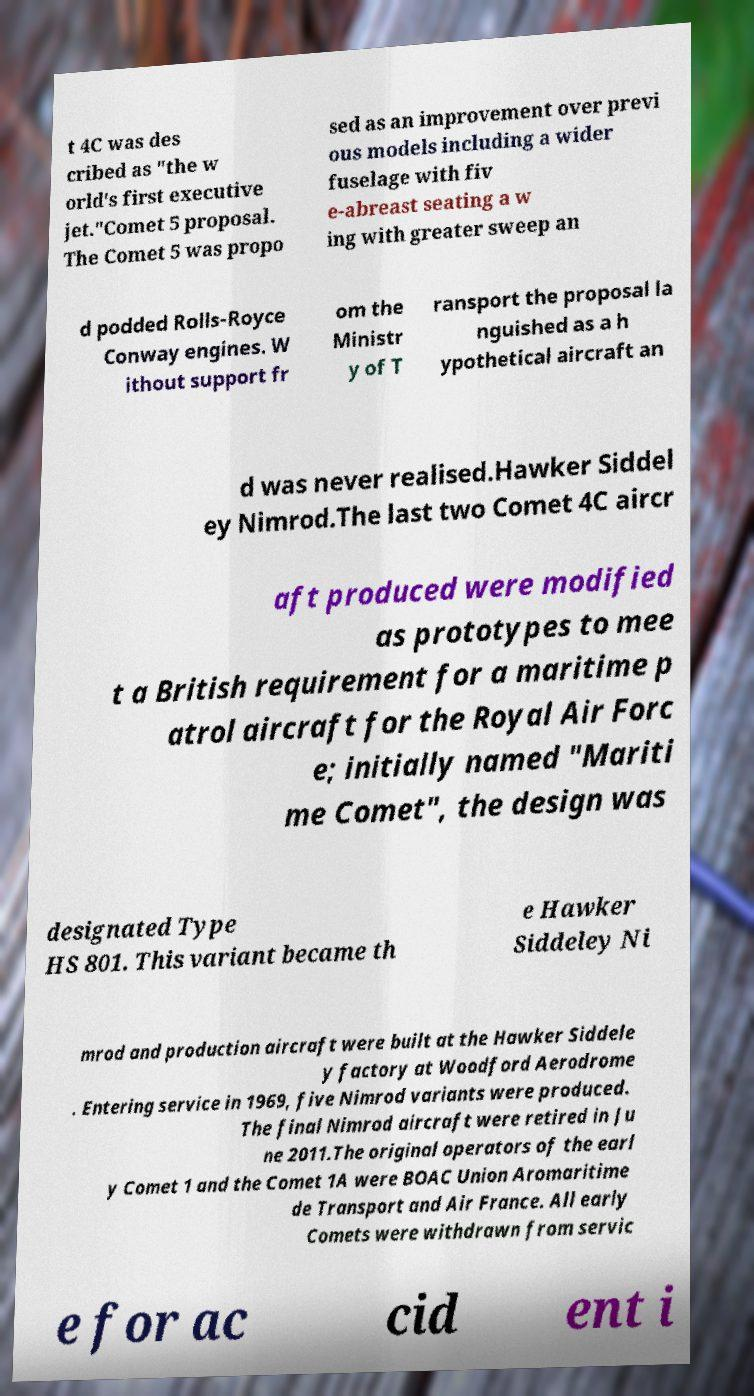What messages or text are displayed in this image? I need them in a readable, typed format. t 4C was des cribed as "the w orld's first executive jet."Comet 5 proposal. The Comet 5 was propo sed as an improvement over previ ous models including a wider fuselage with fiv e-abreast seating a w ing with greater sweep an d podded Rolls-Royce Conway engines. W ithout support fr om the Ministr y of T ransport the proposal la nguished as a h ypothetical aircraft an d was never realised.Hawker Siddel ey Nimrod.The last two Comet 4C aircr aft produced were modified as prototypes to mee t a British requirement for a maritime p atrol aircraft for the Royal Air Forc e; initially named "Mariti me Comet", the design was designated Type HS 801. This variant became th e Hawker Siddeley Ni mrod and production aircraft were built at the Hawker Siddele y factory at Woodford Aerodrome . Entering service in 1969, five Nimrod variants were produced. The final Nimrod aircraft were retired in Ju ne 2011.The original operators of the earl y Comet 1 and the Comet 1A were BOAC Union Aromaritime de Transport and Air France. All early Comets were withdrawn from servic e for ac cid ent i 